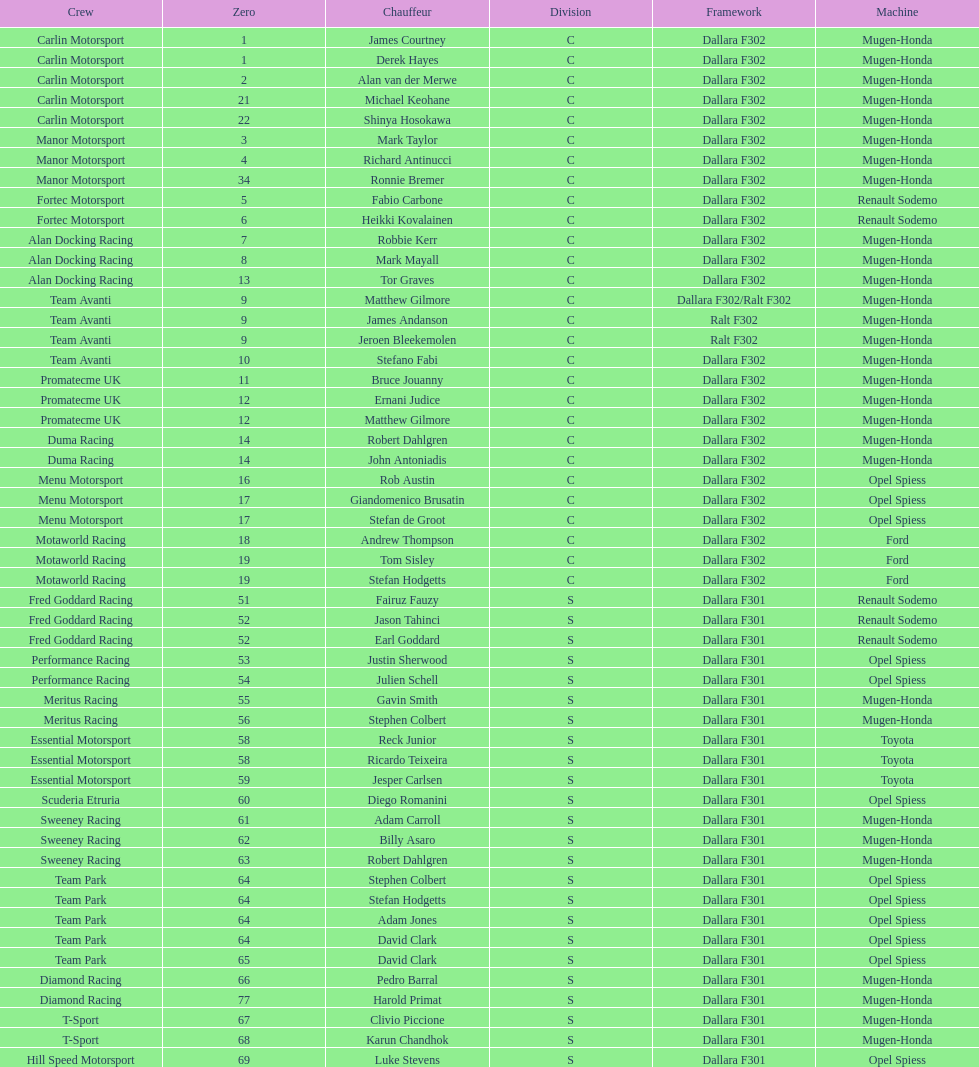Could you parse the entire table? {'header': ['Crew', 'Zero', 'Chauffeur', 'Division', 'Framework', 'Machine'], 'rows': [['Carlin Motorsport', '1', 'James Courtney', 'C', 'Dallara F302', 'Mugen-Honda'], ['Carlin Motorsport', '1', 'Derek Hayes', 'C', 'Dallara F302', 'Mugen-Honda'], ['Carlin Motorsport', '2', 'Alan van der Merwe', 'C', 'Dallara F302', 'Mugen-Honda'], ['Carlin Motorsport', '21', 'Michael Keohane', 'C', 'Dallara F302', 'Mugen-Honda'], ['Carlin Motorsport', '22', 'Shinya Hosokawa', 'C', 'Dallara F302', 'Mugen-Honda'], ['Manor Motorsport', '3', 'Mark Taylor', 'C', 'Dallara F302', 'Mugen-Honda'], ['Manor Motorsport', '4', 'Richard Antinucci', 'C', 'Dallara F302', 'Mugen-Honda'], ['Manor Motorsport', '34', 'Ronnie Bremer', 'C', 'Dallara F302', 'Mugen-Honda'], ['Fortec Motorsport', '5', 'Fabio Carbone', 'C', 'Dallara F302', 'Renault Sodemo'], ['Fortec Motorsport', '6', 'Heikki Kovalainen', 'C', 'Dallara F302', 'Renault Sodemo'], ['Alan Docking Racing', '7', 'Robbie Kerr', 'C', 'Dallara F302', 'Mugen-Honda'], ['Alan Docking Racing', '8', 'Mark Mayall', 'C', 'Dallara F302', 'Mugen-Honda'], ['Alan Docking Racing', '13', 'Tor Graves', 'C', 'Dallara F302', 'Mugen-Honda'], ['Team Avanti', '9', 'Matthew Gilmore', 'C', 'Dallara F302/Ralt F302', 'Mugen-Honda'], ['Team Avanti', '9', 'James Andanson', 'C', 'Ralt F302', 'Mugen-Honda'], ['Team Avanti', '9', 'Jeroen Bleekemolen', 'C', 'Ralt F302', 'Mugen-Honda'], ['Team Avanti', '10', 'Stefano Fabi', 'C', 'Dallara F302', 'Mugen-Honda'], ['Promatecme UK', '11', 'Bruce Jouanny', 'C', 'Dallara F302', 'Mugen-Honda'], ['Promatecme UK', '12', 'Ernani Judice', 'C', 'Dallara F302', 'Mugen-Honda'], ['Promatecme UK', '12', 'Matthew Gilmore', 'C', 'Dallara F302', 'Mugen-Honda'], ['Duma Racing', '14', 'Robert Dahlgren', 'C', 'Dallara F302', 'Mugen-Honda'], ['Duma Racing', '14', 'John Antoniadis', 'C', 'Dallara F302', 'Mugen-Honda'], ['Menu Motorsport', '16', 'Rob Austin', 'C', 'Dallara F302', 'Opel Spiess'], ['Menu Motorsport', '17', 'Giandomenico Brusatin', 'C', 'Dallara F302', 'Opel Spiess'], ['Menu Motorsport', '17', 'Stefan de Groot', 'C', 'Dallara F302', 'Opel Spiess'], ['Motaworld Racing', '18', 'Andrew Thompson', 'C', 'Dallara F302', 'Ford'], ['Motaworld Racing', '19', 'Tom Sisley', 'C', 'Dallara F302', 'Ford'], ['Motaworld Racing', '19', 'Stefan Hodgetts', 'C', 'Dallara F302', 'Ford'], ['Fred Goddard Racing', '51', 'Fairuz Fauzy', 'S', 'Dallara F301', 'Renault Sodemo'], ['Fred Goddard Racing', '52', 'Jason Tahinci', 'S', 'Dallara F301', 'Renault Sodemo'], ['Fred Goddard Racing', '52', 'Earl Goddard', 'S', 'Dallara F301', 'Renault Sodemo'], ['Performance Racing', '53', 'Justin Sherwood', 'S', 'Dallara F301', 'Opel Spiess'], ['Performance Racing', '54', 'Julien Schell', 'S', 'Dallara F301', 'Opel Spiess'], ['Meritus Racing', '55', 'Gavin Smith', 'S', 'Dallara F301', 'Mugen-Honda'], ['Meritus Racing', '56', 'Stephen Colbert', 'S', 'Dallara F301', 'Mugen-Honda'], ['Essential Motorsport', '58', 'Reck Junior', 'S', 'Dallara F301', 'Toyota'], ['Essential Motorsport', '58', 'Ricardo Teixeira', 'S', 'Dallara F301', 'Toyota'], ['Essential Motorsport', '59', 'Jesper Carlsen', 'S', 'Dallara F301', 'Toyota'], ['Scuderia Etruria', '60', 'Diego Romanini', 'S', 'Dallara F301', 'Opel Spiess'], ['Sweeney Racing', '61', 'Adam Carroll', 'S', 'Dallara F301', 'Mugen-Honda'], ['Sweeney Racing', '62', 'Billy Asaro', 'S', 'Dallara F301', 'Mugen-Honda'], ['Sweeney Racing', '63', 'Robert Dahlgren', 'S', 'Dallara F301', 'Mugen-Honda'], ['Team Park', '64', 'Stephen Colbert', 'S', 'Dallara F301', 'Opel Spiess'], ['Team Park', '64', 'Stefan Hodgetts', 'S', 'Dallara F301', 'Opel Spiess'], ['Team Park', '64', 'Adam Jones', 'S', 'Dallara F301', 'Opel Spiess'], ['Team Park', '64', 'David Clark', 'S', 'Dallara F301', 'Opel Spiess'], ['Team Park', '65', 'David Clark', 'S', 'Dallara F301', 'Opel Spiess'], ['Diamond Racing', '66', 'Pedro Barral', 'S', 'Dallara F301', 'Mugen-Honda'], ['Diamond Racing', '77', 'Harold Primat', 'S', 'Dallara F301', 'Mugen-Honda'], ['T-Sport', '67', 'Clivio Piccione', 'S', 'Dallara F301', 'Mugen-Honda'], ['T-Sport', '68', 'Karun Chandhok', 'S', 'Dallara F301', 'Mugen-Honda'], ['Hill Speed Motorsport', '69', 'Luke Stevens', 'S', 'Dallara F301', 'Opel Spiess']]} The two drivers on t-sport are clivio piccione and what other driver? Karun Chandhok. 